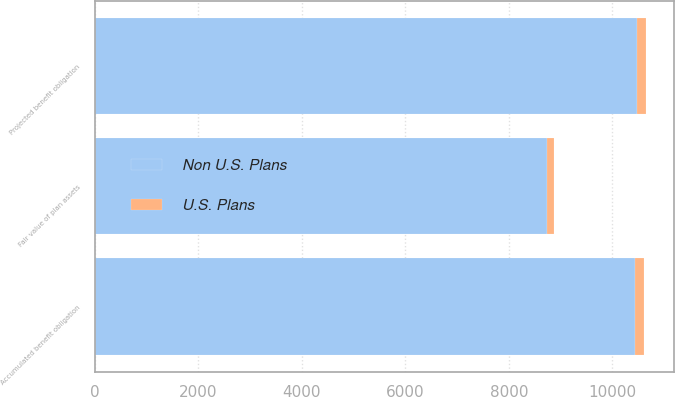Convert chart. <chart><loc_0><loc_0><loc_500><loc_500><stacked_bar_chart><ecel><fcel>Projected benefit obligation<fcel>Accumulated benefit obligation<fcel>Fair value of plan assets<nl><fcel>Non U.S. Plans<fcel>10467<fcel>10440<fcel>8735<nl><fcel>U.S. Plans<fcel>187<fcel>175<fcel>128<nl></chart> 